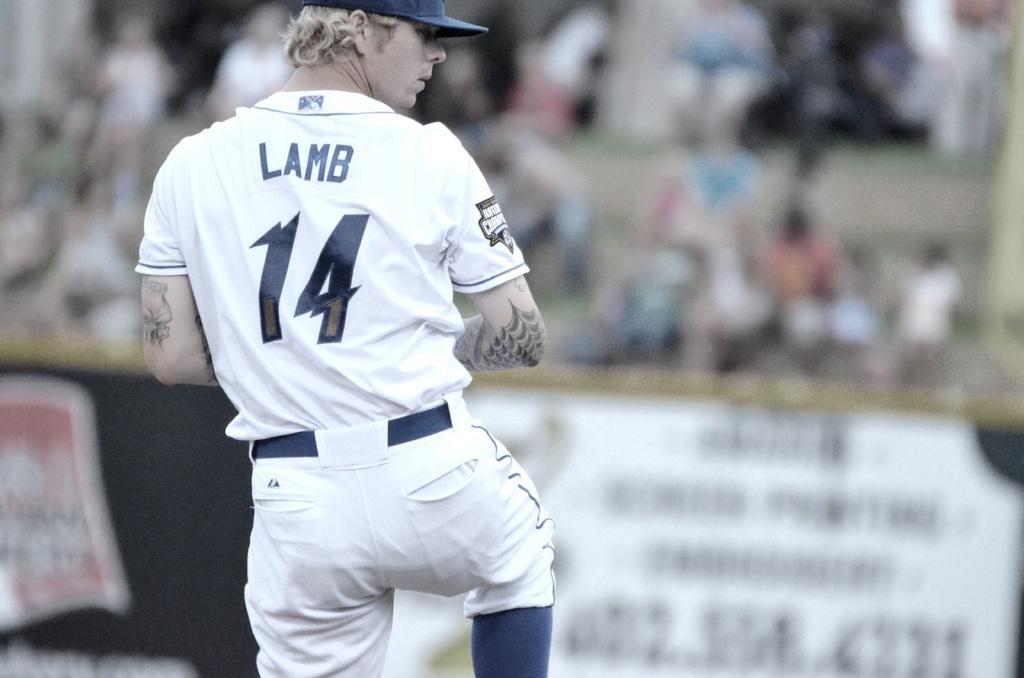<image>
Summarize the visual content of the image. number 14 named Lamb getting ready to pitch the baseball 